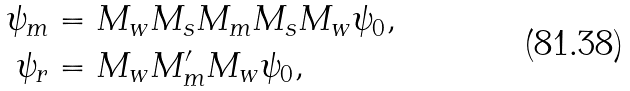Convert formula to latex. <formula><loc_0><loc_0><loc_500><loc_500>\psi _ { m } & = M _ { w } M _ { s } M _ { m } M _ { s } M _ { w } \psi _ { 0 } , \\ \psi _ { r } & = M _ { w } M _ { m } ^ { \prime } M _ { w } \psi _ { 0 } ,</formula> 